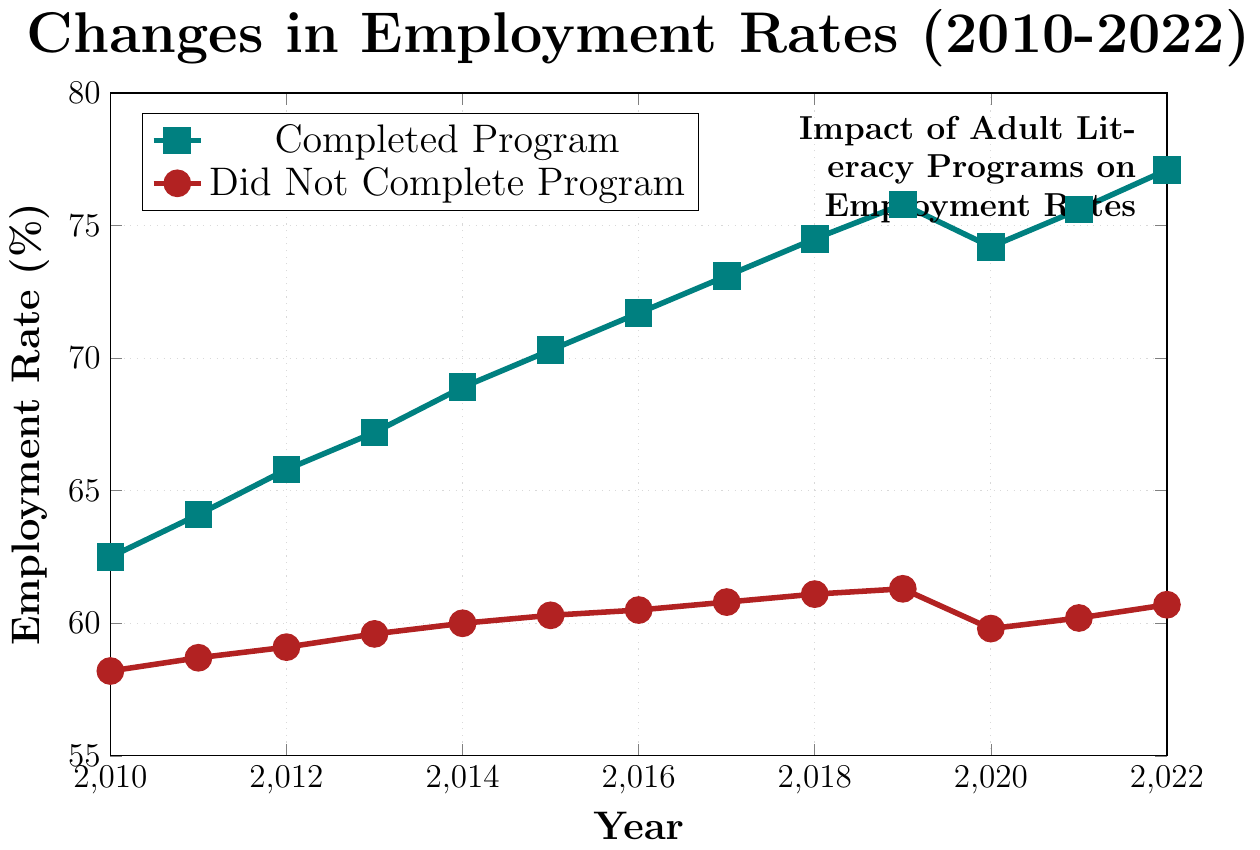What is the difference in employment rates between adults who completed the program and those who didn't in 2022? Look at the employment rates for 2022: 77.1% for those who completed the program and 60.7% for those who didn't. Subtract 60.7 from 77.1 to find the difference. 77.1 - 60.7 = 16.4
Answer: 16.4 What year shows the highest employment rate for adults who completed the program? Refer to the blue line representing "Completed Program". The highest point on this line is at 2022 with an employment rate of 77.1%.
Answer: 2022 What is the average employment rate for adults who did not complete the program between 2010 and 2015? Add the employment rates for "Did Not Complete Program" between 2010 and 2015 (58.2 + 58.7 + 59.1 + 59.6 + 60.0 + 60.3) and divide by the number of years (6). (58.2 + 58.7 + 59.1 + 59.6 + 60.0 + 60.3) / 6 = 59.32
Answer: 59.32 How did the employment rate for adults who completed the program change from 2019 to 2020? Check the employment rates for "Completed Program" in 2019 and 2020: 75.8% and 74.2%, respectively. The change is 74.2 - 75.8 = -1.6, indicating a decrease.
Answer: Decreased by 1.6 Between which consecutive years did adults who did not complete the program experience the highest increase in employment rate? Compare the year-to-year increases for the "Did Not Complete Program" line. The largest increase is between 2011 (58.7%) and 2012 (59.1%), which is 59.1 - 58.7 = 0.4.
Answer: 2011 to 2012 What is the overall trend for the employment rates of adults who completed the program from 2010 to 2022? Observe the blue line for the "Completed Program". The overall trend shows an upward slope from 62.5% in 2010 to 77.1% in 2022 despite a slight dip in 2020.
Answer: Upward trend Compare the employment rates in 2013 for adults who completed the program versus those who didn't. Which group had a higher rate and by how much? In 2013, the employment rate for those who completed the program was 67.2%, while for those who didn't, it was 59.6%. The difference is 67.2 - 59.6 = 7.6. The "Completed Program" group had a higher rate.
Answer: Completed Program by 7.6 What was the impact of the literacy program on employment rates during the economic slump of 2020? In 2020, the employment rate for those who completed the program dipped slightly to 74.2%, whereas for those who didn't, the rate fell more significantly to 59.8%. This suggests that while both groups were affected, those who completed the program experienced a smaller decrease.
Answer: Smaller decrease for those who completed the program What year has the lowest employment rate for adults who did not complete the program, and what is the rate? The lowest point on the red line for "Did Not Complete Program" shows the employment rate in 2010 as 58.2%.
Answer: 2010 with 58.2% How does the employment rate in 2018 compare between the two groups? In 2018, the employment rate for those who completed the program was 74.5%, and for those who didn't, it was 61.1%. The difference is 74.5 - 61.1 = 13.4, indicating a higher rate for those who completed the program.
Answer: Completed Program by 13.4 